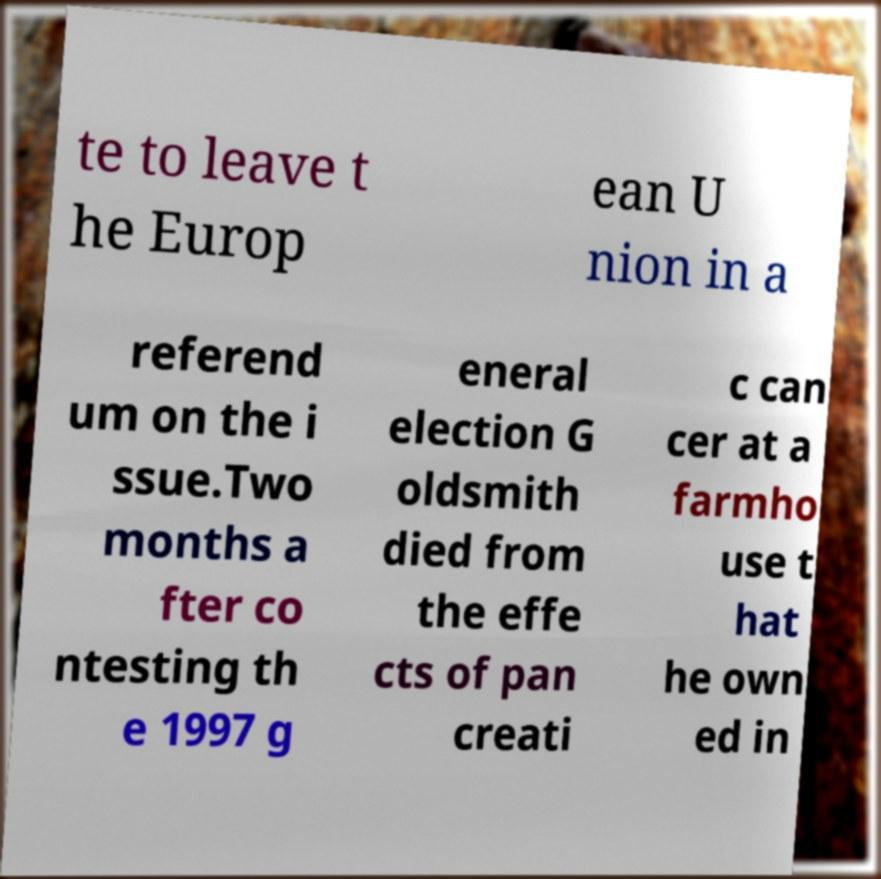There's text embedded in this image that I need extracted. Can you transcribe it verbatim? te to leave t he Europ ean U nion in a referend um on the i ssue.Two months a fter co ntesting th e 1997 g eneral election G oldsmith died from the effe cts of pan creati c can cer at a farmho use t hat he own ed in 